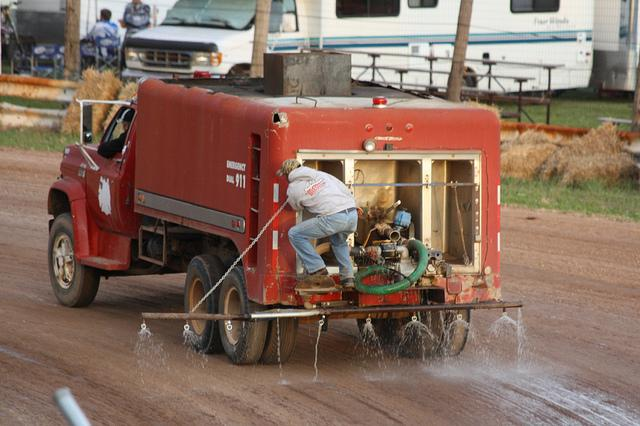How did he get on back of the truck?

Choices:
A) climbed on
B) fell on
C) lives there
D) jumped on climbed on 